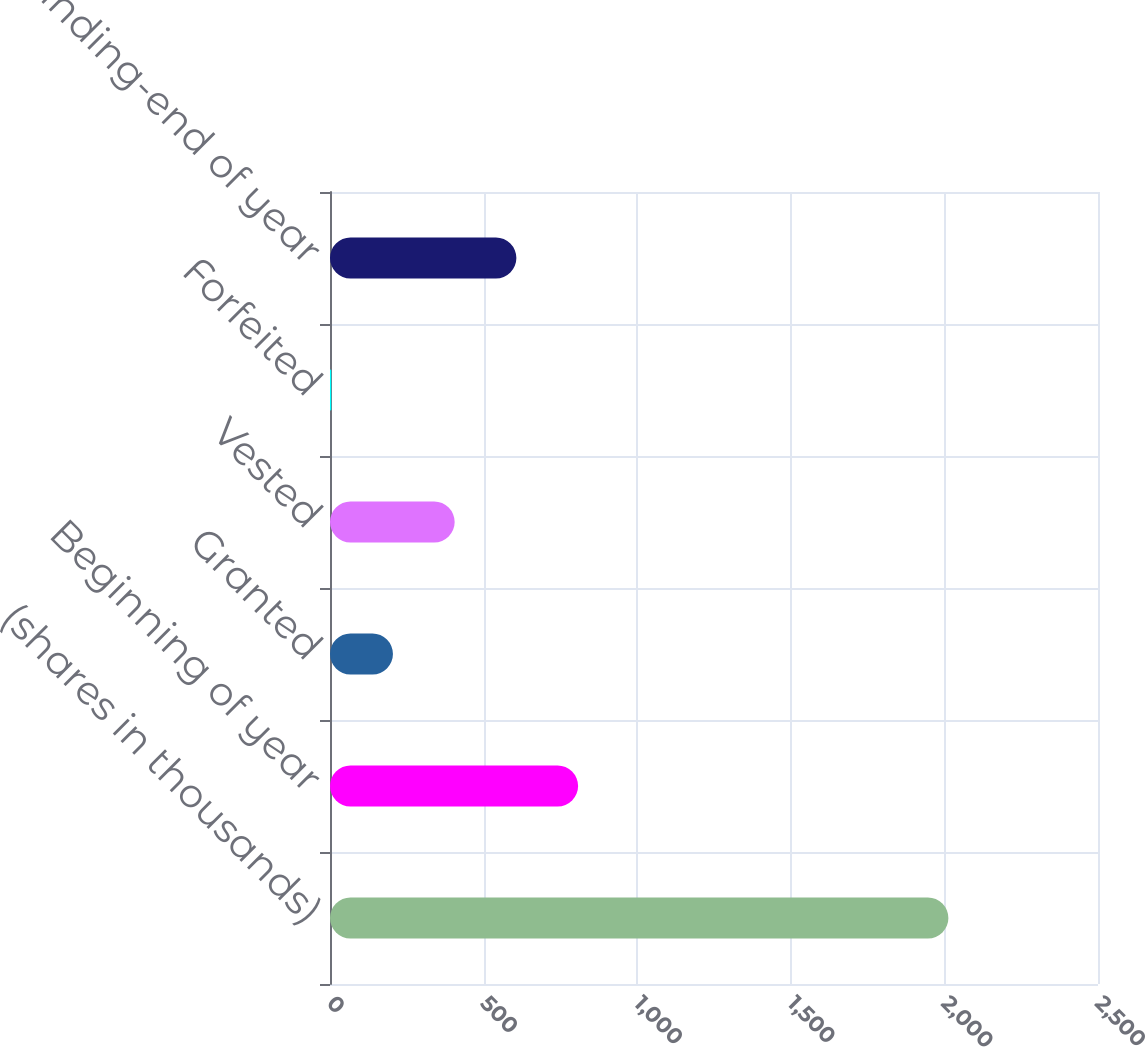<chart> <loc_0><loc_0><loc_500><loc_500><bar_chart><fcel>(shares in thousands)<fcel>Beginning of year<fcel>Granted<fcel>Vested<fcel>Forfeited<fcel>Outstanding-end of year<nl><fcel>2013<fcel>807.6<fcel>204.9<fcel>405.8<fcel>4<fcel>606.7<nl></chart> 